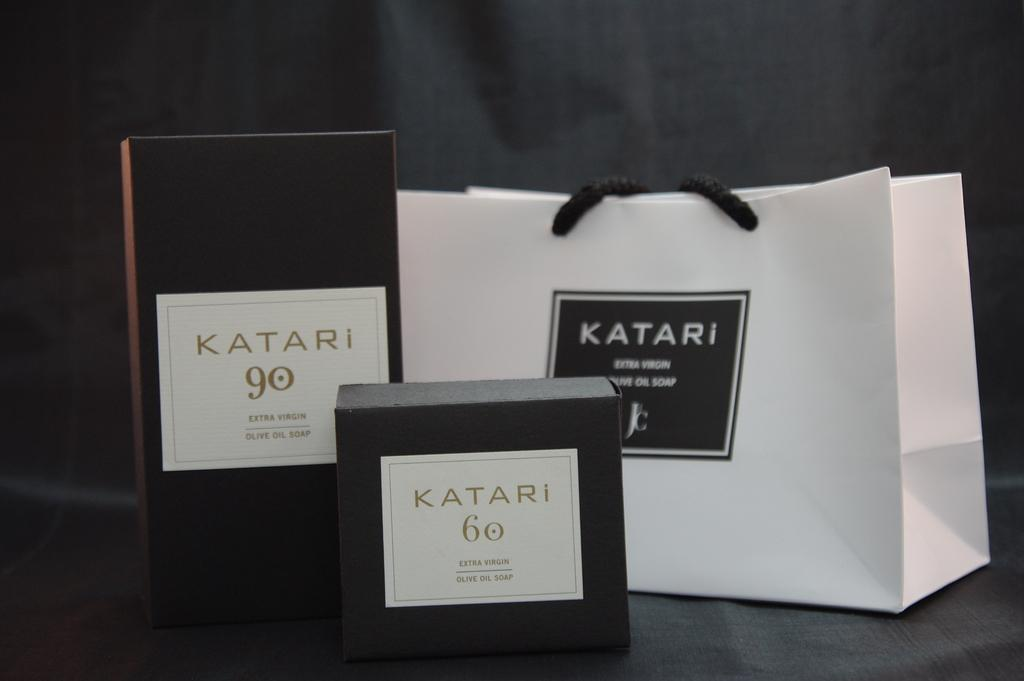Provide a one-sentence caption for the provided image. Three items sitting on a table advertising Katari. 